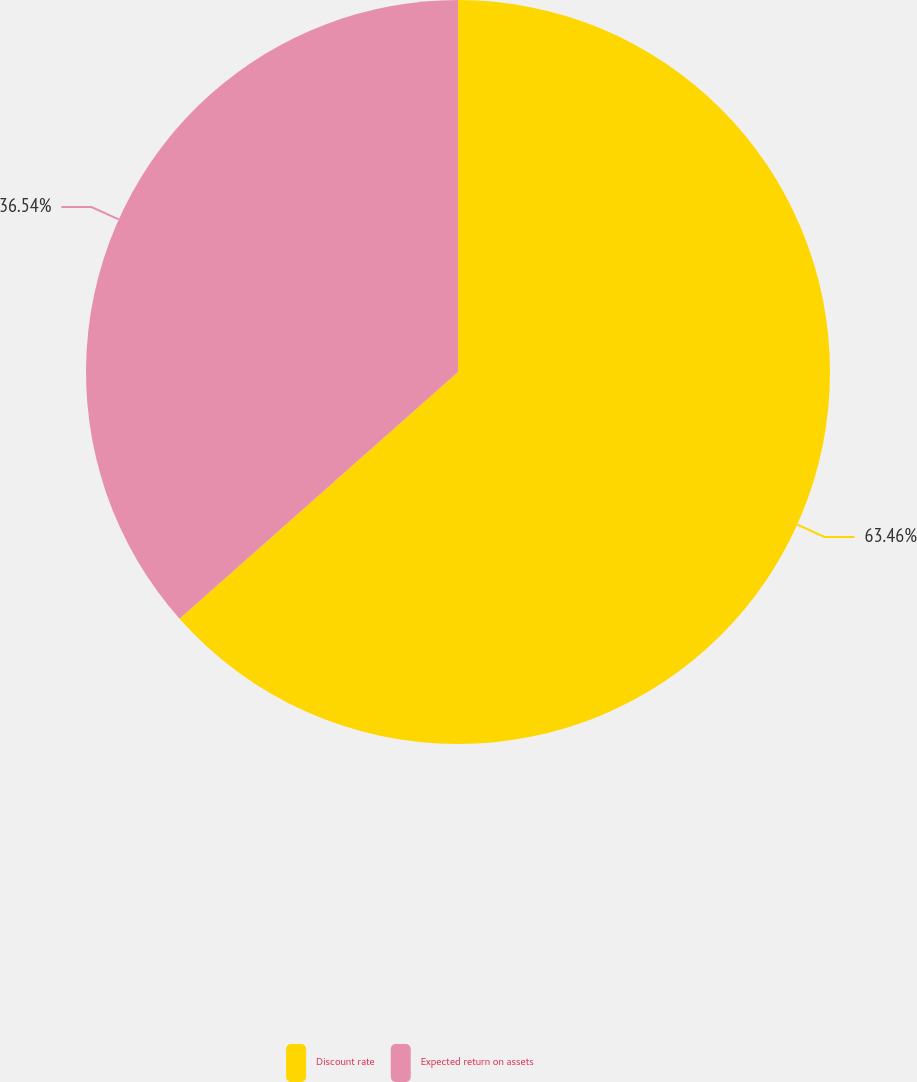Convert chart to OTSL. <chart><loc_0><loc_0><loc_500><loc_500><pie_chart><fcel>Discount rate<fcel>Expected return on assets<nl><fcel>63.46%<fcel>36.54%<nl></chart> 